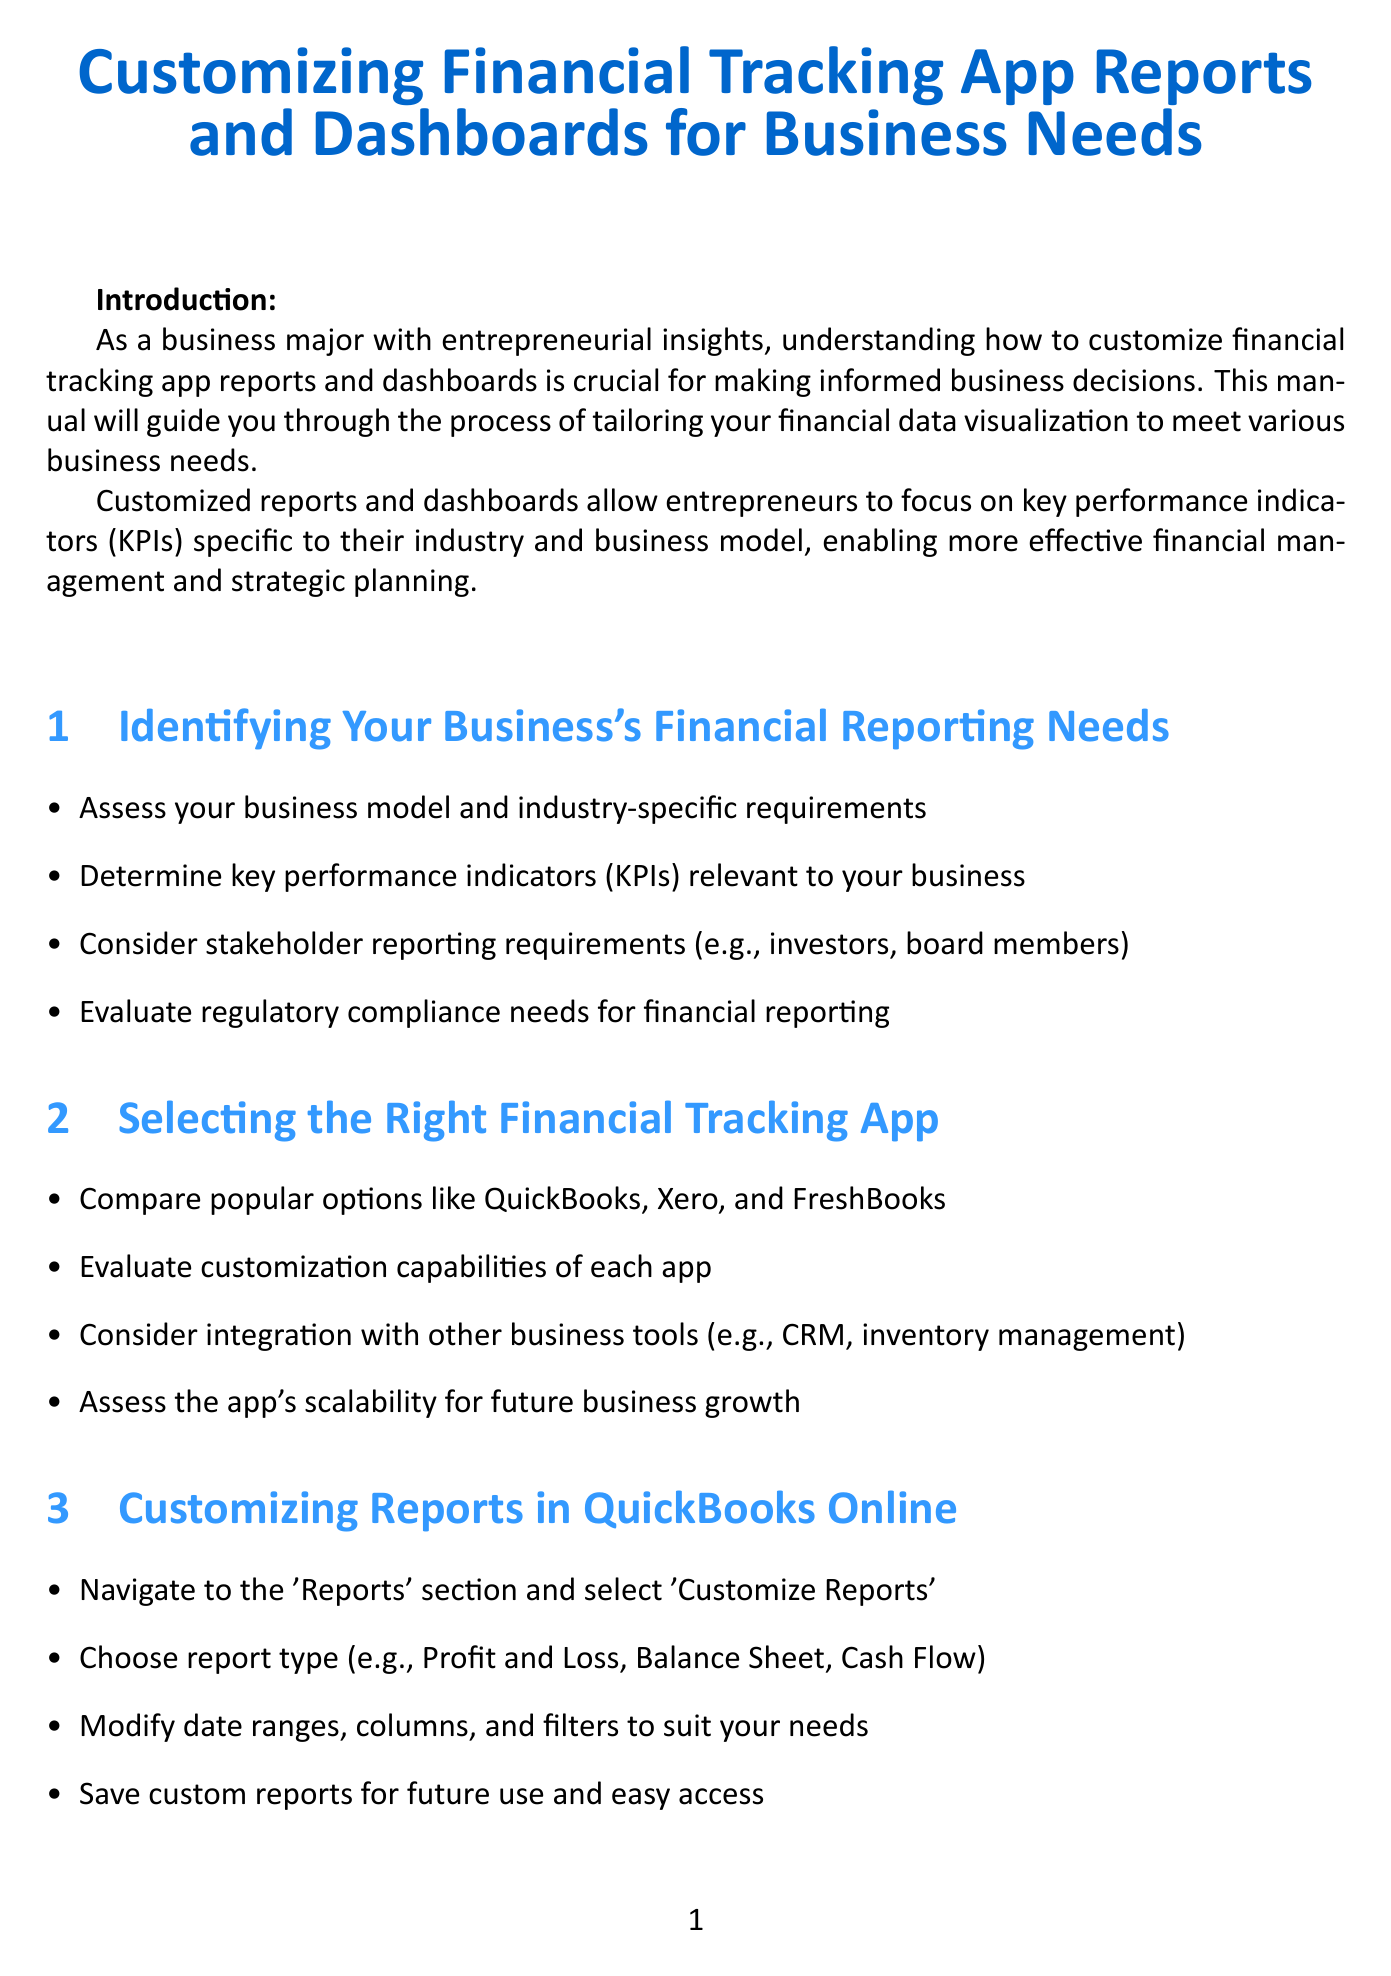What is the title of the manual? The title is the main heading of the document and introduces the subject matter.
Answer: Customizing Financial Tracking App Reports and Dashboards for Business Needs What is one of the key performance indicators mentioned in the document? KPIs are highlighted as crucial metrics for businesses, and the document suggests determining relevant KPIs.
Answer: Key performance indicators Which app is mentioned first in the section about selecting the right financial tracking app? The order of apps listed reflects the author's recommendation for comparison in the selection process.
Answer: QuickBooks What is a customization technique suggested for financial reports? Techniques for customization are included in different sections of the manual, offering ideas for deeper analysis.
Answer: Pivot tables How many steps are suggested for customizing reports in QuickBooks Online? The bullet points outline several distinct actions that can be taken to customize reports.
Answer: Four What type of authentication is recommended for enhancing data security? The document emphasizes the importance of security measures to protect financial data.
Answer: Two-factor authentication What is the focus of the best practices section mentioned in the document? This section discusses principles and guidelines to design effective financial dashboards.
Answer: Clarity and simplicity Which tool can be connected with financial tracking apps for advanced analysis? Mentioned tools enhance the analysis capabilities of financial data gathered from apps.
Answer: Tableau What should users regularly do regarding their financial data? This advice emphasizes the importance of maintaining the integrity and safety of financial information.
Answer: Backup financial data 